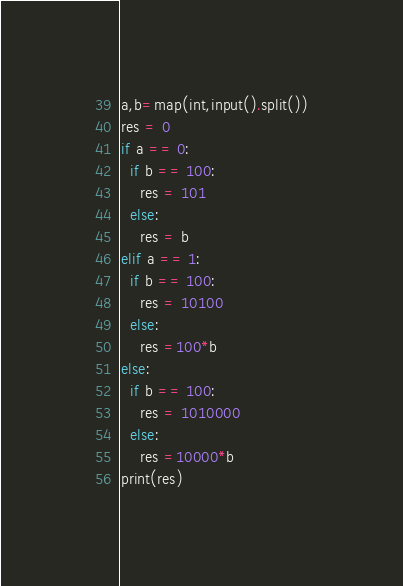Convert code to text. <code><loc_0><loc_0><loc_500><loc_500><_Python_>a,b=map(int,input().split())
res = 0
if a == 0:
  if b == 100:
    res = 101
  else:
    res = b
elif a == 1:
  if b == 100:
    res = 10100
  else:
    res =100*b
else:
  if b == 100:
    res = 1010000
  else:
    res =10000*b
print(res)</code> 